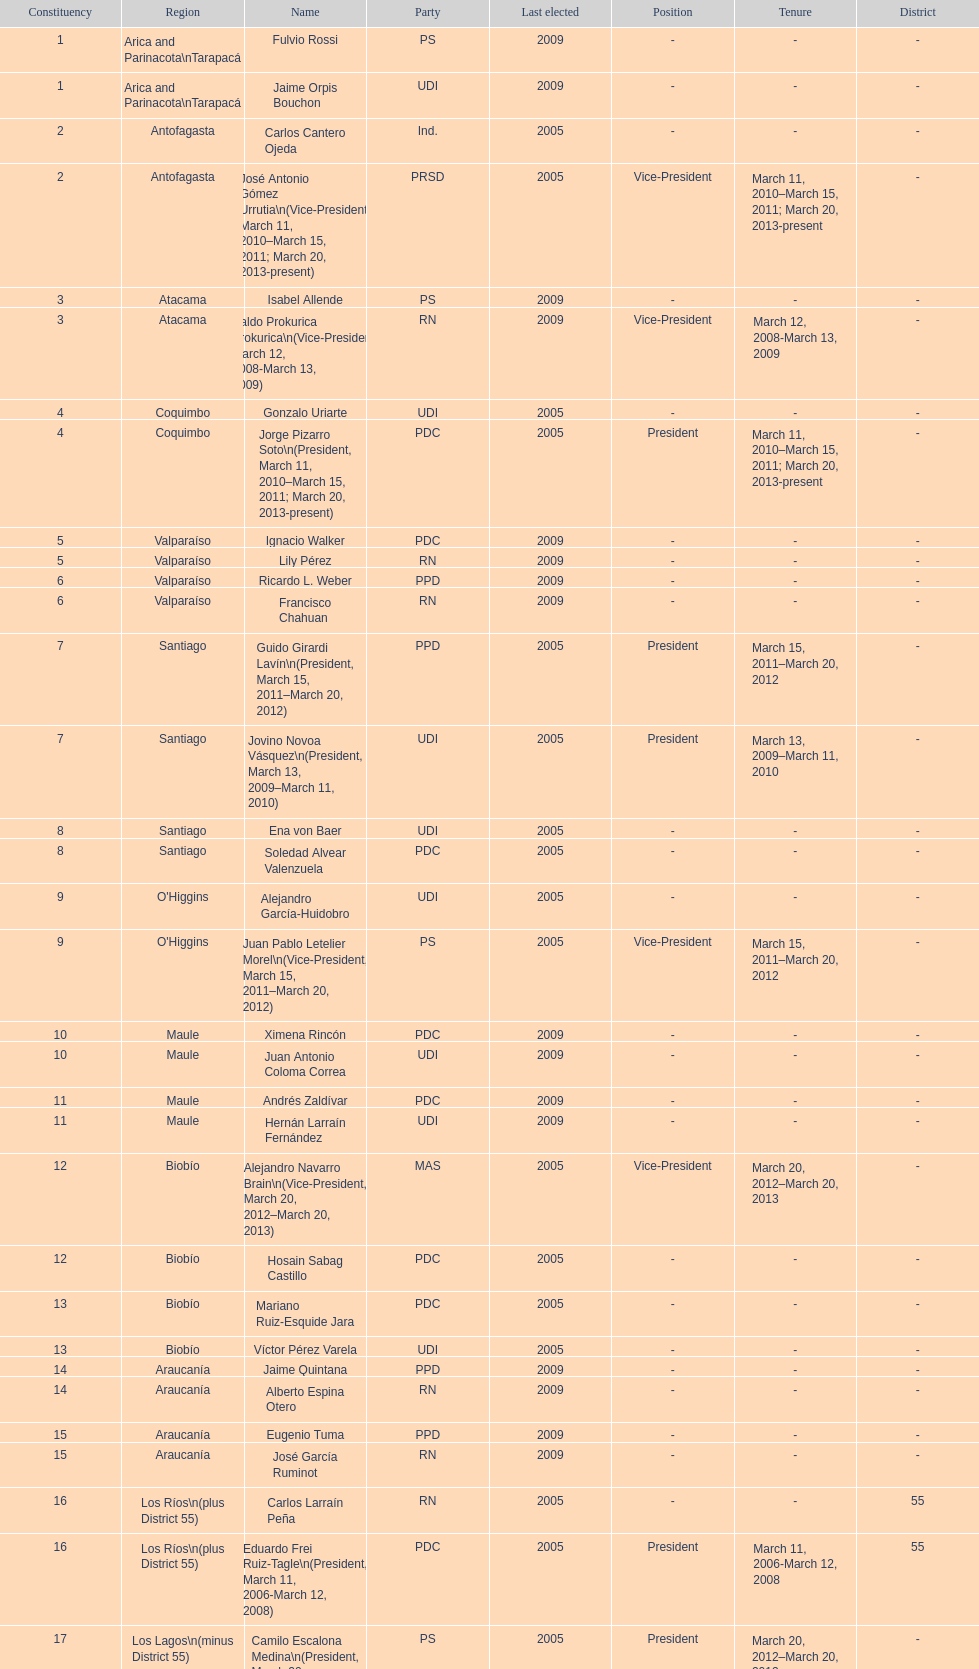What is the total number of constituencies? 19. 